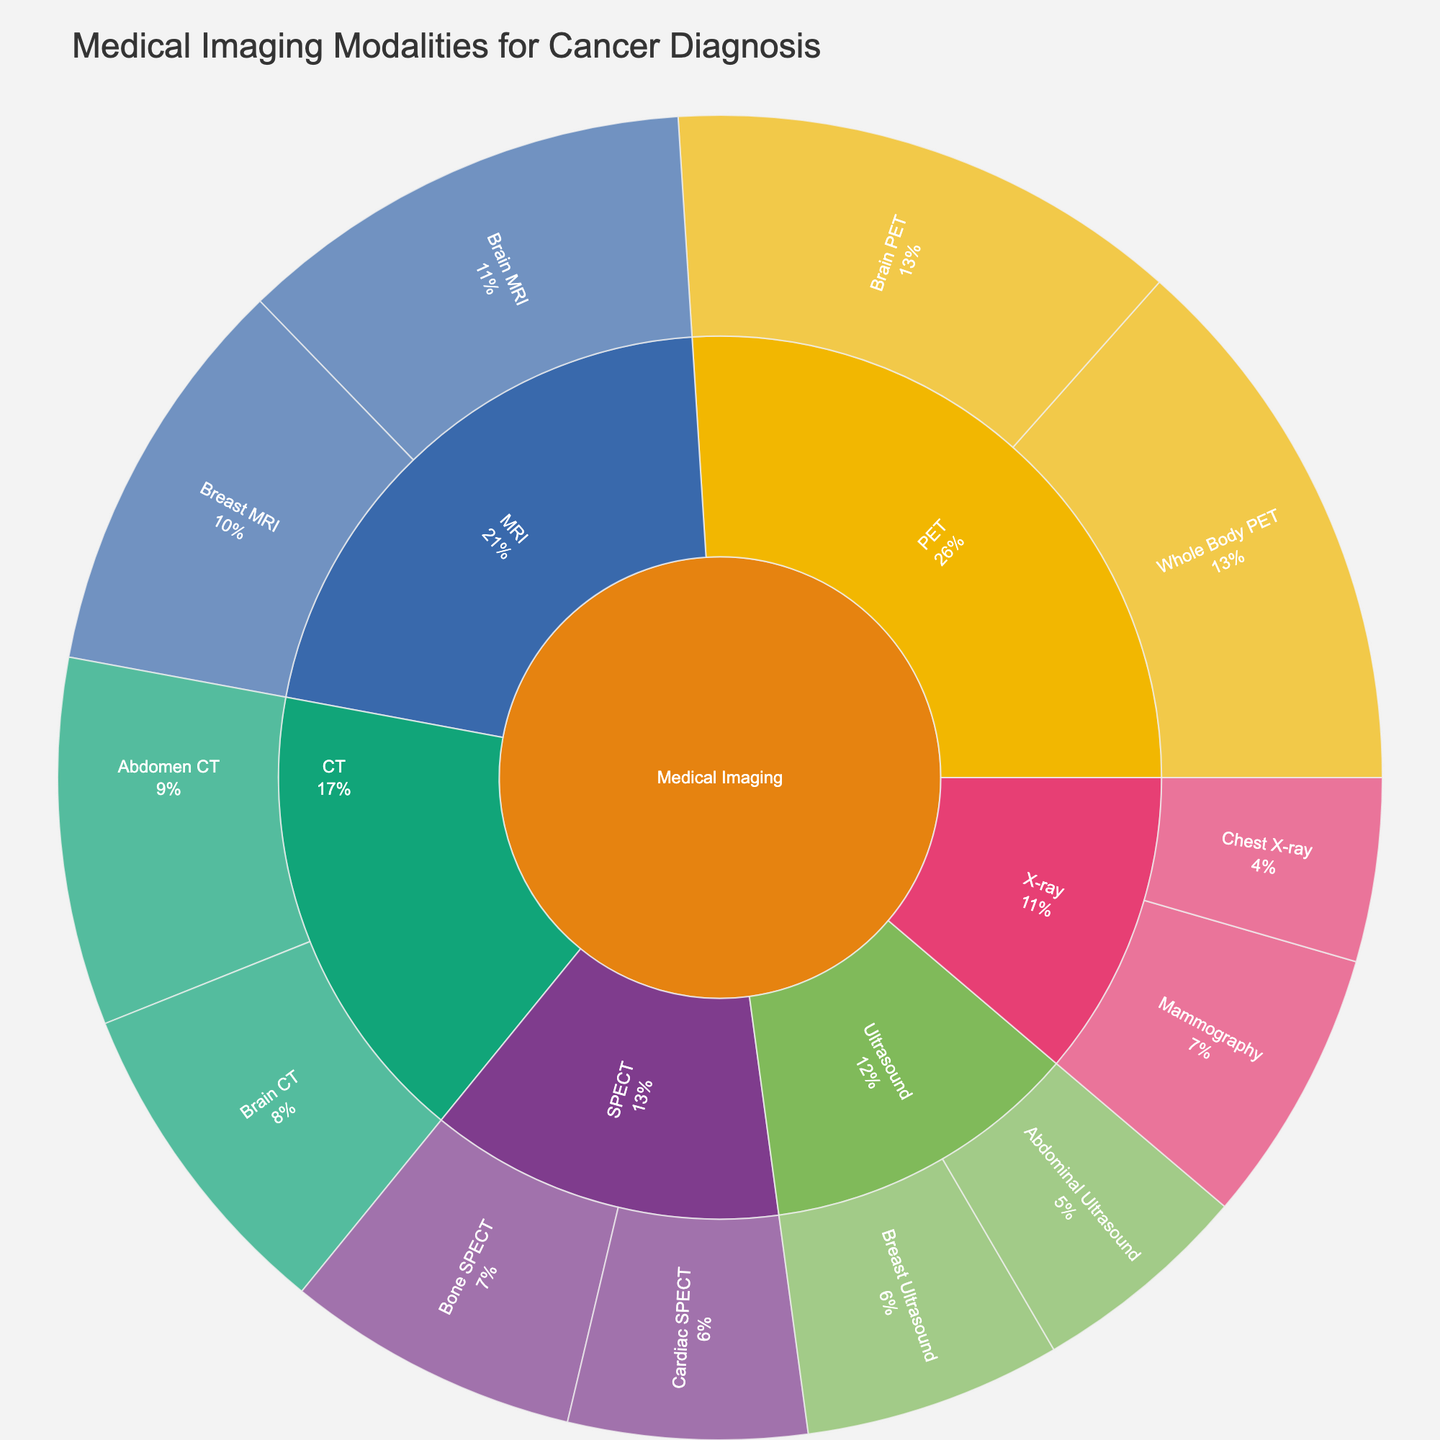What's the title of the plot? The title of the plot is usually placed at the top and is intended to provide a summary of what the figure represents. In this case, it reads, "Medical Imaging Modalities for Cancer Diagnosis".
Answer: Medical Imaging Modalities for Cancer Diagnosis Which category has the highest overall value? To find the category with the highest value, look at the root categories and compare their values. PET has the highest combined value of 58 (Whole Body PET 30 + Brain PET 28).
Answer: PET How much higher is the value of Brain MRI compared to Brain CT? First, note the values for Brain MRI (25) and Brain CT (18). Subtract the value of Brain CT from Brain MRI: 25 - 18.
Answer: 7 What is the total value of all X-ray subcategories? Add the values of the subcategories that fall under X-ray: Chest X-ray (10) and Mammography (15). The total value is 10 + 15.
Answer: 25 Which subcategory has the lowest value? To determine the subcategory with the lowest value, look at all the subcategories and their respective values. The subcategory with the lowest value here is Chest X-ray, which has a value of 10.
Answer: Chest X-ray What is the combined value of all CT subcategories? Add the values of all subcategories under CT: Abdomen CT (20) and Brain CT (18). The combined value is 20 + 18.
Answer: 38 How does the value of Abdominal Ultrasound compare to Cardiac SPECT? Compare the values of Abdominal Ultrasound (12) and Cardiac SPECT (13) directly. Cardiac SPECT is 1 unit higher than Abdominal Ultrasound.
Answer: Cardiac SPECT is higher by 1 What percentage of the total value does Whole Body PET represent? Sum all values (10+15+20+18+25+22+12+14+30+28+16+13 = 223). The percentage is (30/223) x 100.
Answer: 13.5% What's the average value of MRI subcategories? First, get the values of the MRI subcategories: Brain MRI (25) and Breast MRI (22). Calculate the average: (25 + 22) / 2.
Answer: 23.5 